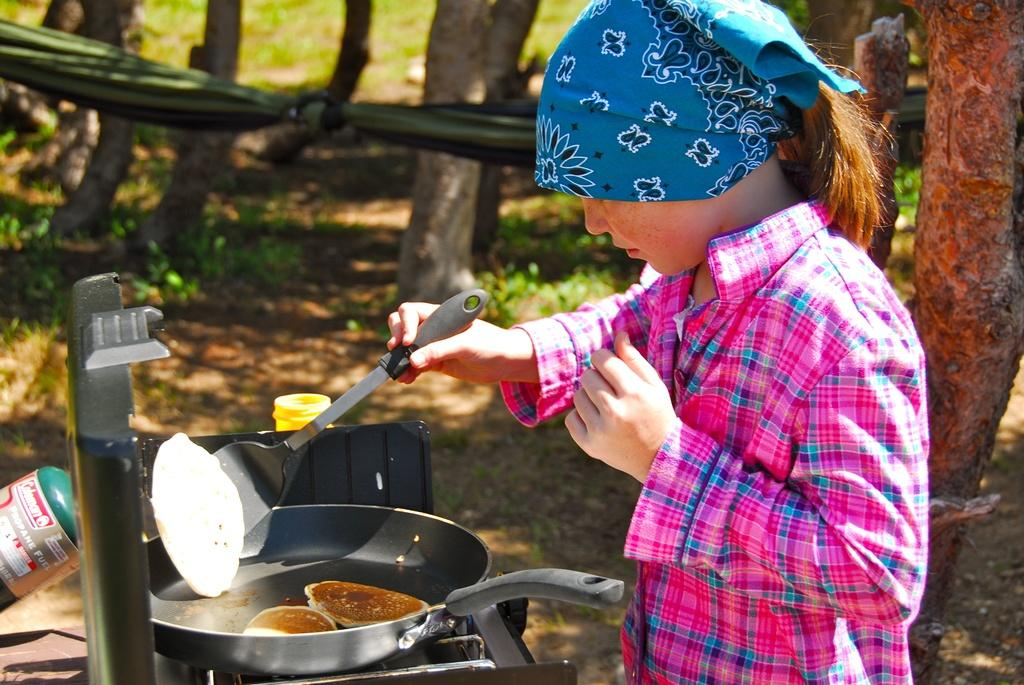Who is the main subject in the image? There is a woman in the image. What is the woman doing in the image? The woman is standing and holding a spoon. What can be seen in the background of the image? There are tree trunks visible in the background of the image. Are there any other objects present in the image? Yes, there are other objects present in the image. What type of ship can be seen in the image? There is no ship present in the image. What is the woman's destination on her journey in the image? The image does not depict a journey or a destination, so it is not possible to answer that question. 